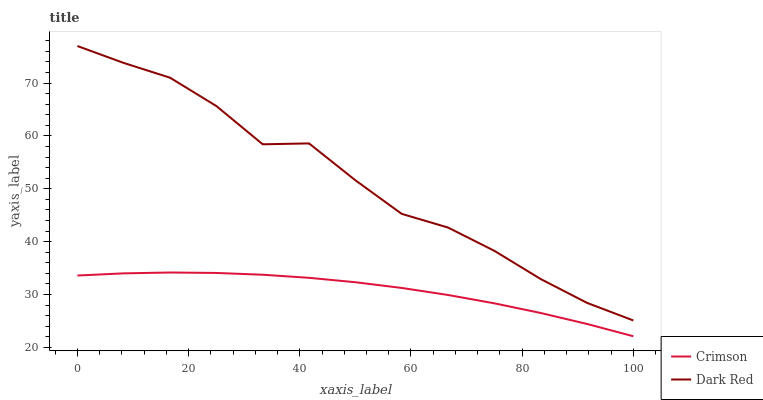Does Crimson have the minimum area under the curve?
Answer yes or no. Yes. Does Dark Red have the maximum area under the curve?
Answer yes or no. Yes. Does Dark Red have the minimum area under the curve?
Answer yes or no. No. Is Crimson the smoothest?
Answer yes or no. Yes. Is Dark Red the roughest?
Answer yes or no. Yes. Is Dark Red the smoothest?
Answer yes or no. No. Does Crimson have the lowest value?
Answer yes or no. Yes. Does Dark Red have the lowest value?
Answer yes or no. No. Does Dark Red have the highest value?
Answer yes or no. Yes. Is Crimson less than Dark Red?
Answer yes or no. Yes. Is Dark Red greater than Crimson?
Answer yes or no. Yes. Does Crimson intersect Dark Red?
Answer yes or no. No. 